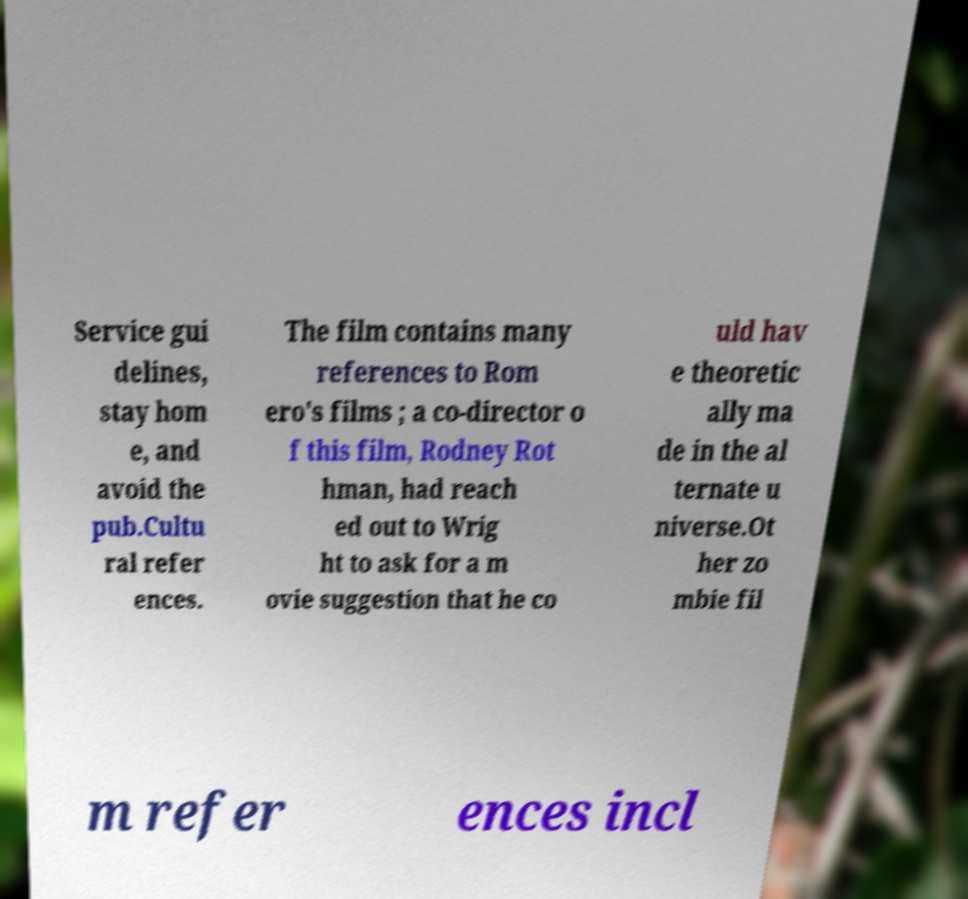Can you read and provide the text displayed in the image?This photo seems to have some interesting text. Can you extract and type it out for me? Service gui delines, stay hom e, and avoid the pub.Cultu ral refer ences. The film contains many references to Rom ero's films ; a co-director o f this film, Rodney Rot hman, had reach ed out to Wrig ht to ask for a m ovie suggestion that he co uld hav e theoretic ally ma de in the al ternate u niverse.Ot her zo mbie fil m refer ences incl 